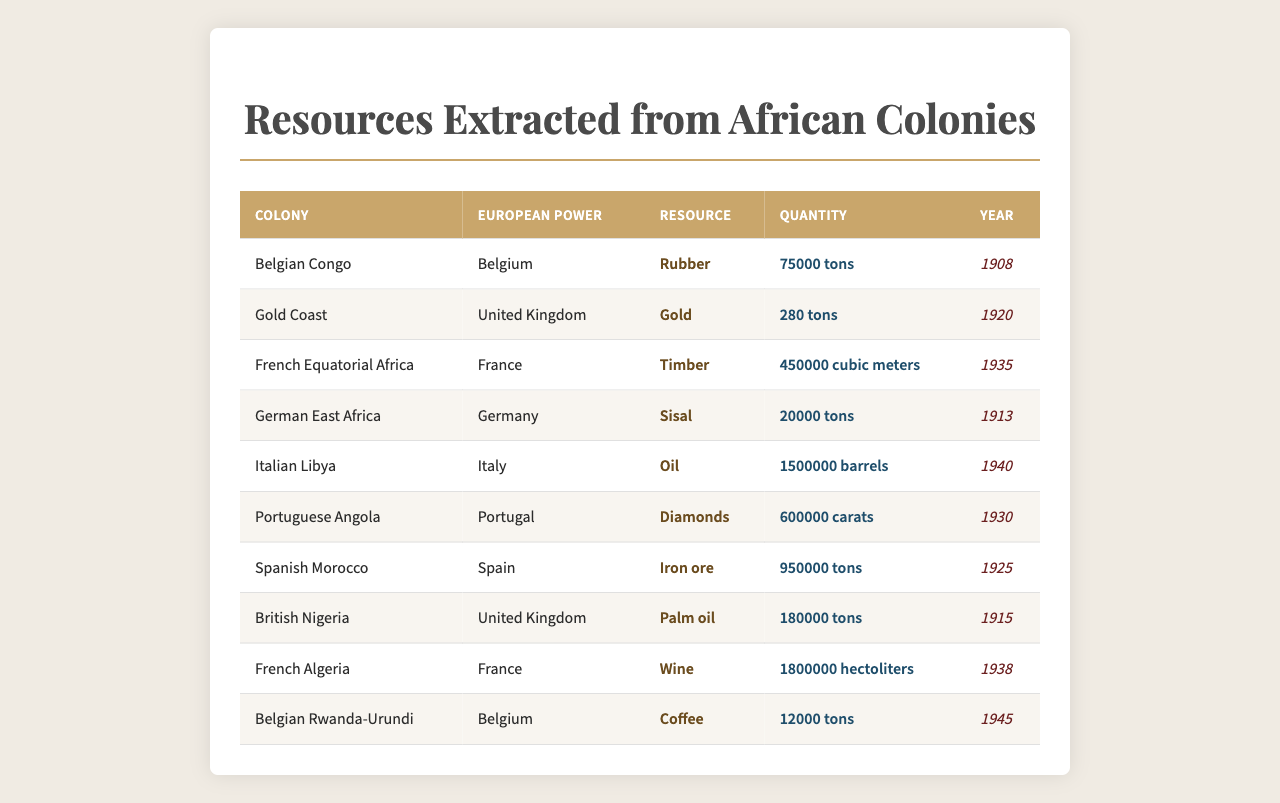What is the total quantity of rubber extracted from the Belgian Congo? The table shows that 75,000 tons of rubber were extracted from the Belgian Congo in 1908.
Answer: 75,000 tons Which European power obtained the most diamonds from its African colony? The table indicates that Portugal extracted 600,000 carats of diamonds from Portuguese Angola, which is higher than any other recorded amount for diamonds.
Answer: Portugal What is the average quantity of resources extracted in tons from British colonies? From the table, British colonies include British Nigeria (180,000 tons of palm oil) and Gold Coast (280 tons of gold). The average is thus (180,000 + 280) / 2 = 90,140 tons.
Answer: 90,140 tons Did France extract more timber than the United Kingdom extracted gold? The table shows France extracting 450,000 cubic meters of timber while the UK extracted only 280 tons of gold. Since 1 ton of gold equals approximately 1 cubic meter, it can be inferred that France extracted more.
Answer: Yes What resource had the highest single quantity extracted, and from which colony did it come? By examining the table, the highest quantity is 1,500,000 barrels of oil from Italian Libya in 1940.
Answer: Oil from Italian Libya How much more iron ore did Spain extract compared to the coffee extracted from Belgian Rwanda-Urundi? Spain extracted 950,000 tons of iron ore, while Belgium extracted 12,000 tons of coffee. The difference is 950,000 - 12,000 = 938,000 tons.
Answer: 938,000 tons Was the quantity of wine extracted from French Algeria greater than the total quantity of palm oil from Nigeria? French Algeria extracted 1,800,000 hectoliters of wine, while Nigeria extracted 180,000 tons of palm oil. Since 1 ton is equivalent to approximately 98 hectoliters, Nigeria's total equals about 17,647 hectoliters, which is much less than France.
Answer: Yes What is the resource extracted by Germany in 1913, and how does its quantity compare to the quantity of coffee extracted from Rwanda? The resource extracted by Germany in 1913 was sisal, with a quantity of 20,000 tons, while Rwanda produced 12,000 tons of coffee. So, 20,000 tons of sisal is greater than 12,000 tons of coffee.
Answer: Greater (20,000 tons vs. 12,000 tons) Which colony had the least quantity of resources extracted in the total data provided? The table data indicates Belgian Rwanda-Urundi, with only 12,000 tons of coffee extracted.
Answer: Belgian Rwanda-Urundi From which colony did the European power France extract wine, and how many hectoliters were extracted? France extracted wine from the colony of French Algeria, with a total of 1,800,000 hectoliters extracted.
Answer: French Algeria, 1,800,000 hectoliters 